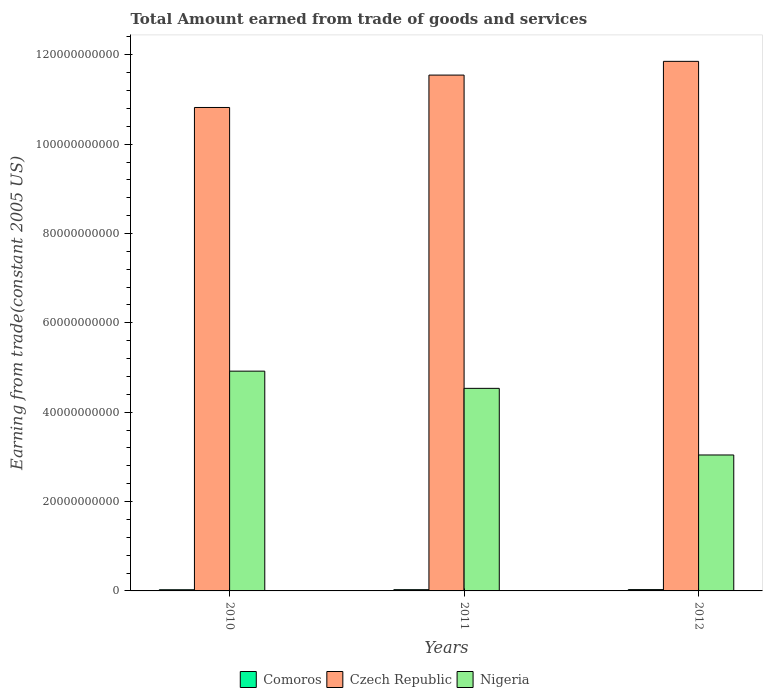How many different coloured bars are there?
Ensure brevity in your answer.  3. Are the number of bars on each tick of the X-axis equal?
Make the answer very short. Yes. How many bars are there on the 2nd tick from the left?
Provide a short and direct response. 3. What is the total amount earned by trading goods and services in Czech Republic in 2011?
Give a very brief answer. 1.15e+11. Across all years, what is the maximum total amount earned by trading goods and services in Nigeria?
Ensure brevity in your answer.  4.92e+1. Across all years, what is the minimum total amount earned by trading goods and services in Comoros?
Your answer should be very brief. 2.64e+08. In which year was the total amount earned by trading goods and services in Czech Republic minimum?
Your answer should be compact. 2010. What is the total total amount earned by trading goods and services in Czech Republic in the graph?
Keep it short and to the point. 3.42e+11. What is the difference between the total amount earned by trading goods and services in Nigeria in 2011 and that in 2012?
Offer a terse response. 1.49e+1. What is the difference between the total amount earned by trading goods and services in Czech Republic in 2010 and the total amount earned by trading goods and services in Nigeria in 2012?
Your answer should be compact. 7.78e+1. What is the average total amount earned by trading goods and services in Nigeria per year?
Ensure brevity in your answer.  4.17e+1. In the year 2011, what is the difference between the total amount earned by trading goods and services in Comoros and total amount earned by trading goods and services in Nigeria?
Give a very brief answer. -4.51e+1. In how many years, is the total amount earned by trading goods and services in Comoros greater than 28000000000 US$?
Offer a terse response. 0. What is the ratio of the total amount earned by trading goods and services in Comoros in 2011 to that in 2012?
Offer a very short reply. 0.94. Is the difference between the total amount earned by trading goods and services in Comoros in 2011 and 2012 greater than the difference between the total amount earned by trading goods and services in Nigeria in 2011 and 2012?
Offer a very short reply. No. What is the difference between the highest and the second highest total amount earned by trading goods and services in Nigeria?
Ensure brevity in your answer.  3.85e+09. What is the difference between the highest and the lowest total amount earned by trading goods and services in Comoros?
Your answer should be compact. 3.07e+07. In how many years, is the total amount earned by trading goods and services in Comoros greater than the average total amount earned by trading goods and services in Comoros taken over all years?
Your answer should be compact. 1. Is the sum of the total amount earned by trading goods and services in Comoros in 2011 and 2012 greater than the maximum total amount earned by trading goods and services in Czech Republic across all years?
Offer a very short reply. No. What does the 3rd bar from the left in 2012 represents?
Your answer should be very brief. Nigeria. What does the 2nd bar from the right in 2012 represents?
Your answer should be very brief. Czech Republic. How many bars are there?
Ensure brevity in your answer.  9. How many years are there in the graph?
Keep it short and to the point. 3. What is the difference between two consecutive major ticks on the Y-axis?
Offer a very short reply. 2.00e+1. Does the graph contain grids?
Provide a short and direct response. No. Where does the legend appear in the graph?
Offer a terse response. Bottom center. How many legend labels are there?
Your answer should be very brief. 3. What is the title of the graph?
Provide a succinct answer. Total Amount earned from trade of goods and services. What is the label or title of the X-axis?
Make the answer very short. Years. What is the label or title of the Y-axis?
Provide a short and direct response. Earning from trade(constant 2005 US). What is the Earning from trade(constant 2005 US) in Comoros in 2010?
Your response must be concise. 2.64e+08. What is the Earning from trade(constant 2005 US) of Czech Republic in 2010?
Your answer should be compact. 1.08e+11. What is the Earning from trade(constant 2005 US) of Nigeria in 2010?
Your answer should be compact. 4.92e+1. What is the Earning from trade(constant 2005 US) of Comoros in 2011?
Make the answer very short. 2.78e+08. What is the Earning from trade(constant 2005 US) of Czech Republic in 2011?
Your answer should be compact. 1.15e+11. What is the Earning from trade(constant 2005 US) in Nigeria in 2011?
Ensure brevity in your answer.  4.53e+1. What is the Earning from trade(constant 2005 US) of Comoros in 2012?
Offer a terse response. 2.95e+08. What is the Earning from trade(constant 2005 US) of Czech Republic in 2012?
Your answer should be compact. 1.19e+11. What is the Earning from trade(constant 2005 US) of Nigeria in 2012?
Your response must be concise. 3.04e+1. Across all years, what is the maximum Earning from trade(constant 2005 US) of Comoros?
Provide a short and direct response. 2.95e+08. Across all years, what is the maximum Earning from trade(constant 2005 US) in Czech Republic?
Offer a terse response. 1.19e+11. Across all years, what is the maximum Earning from trade(constant 2005 US) of Nigeria?
Offer a terse response. 4.92e+1. Across all years, what is the minimum Earning from trade(constant 2005 US) in Comoros?
Your answer should be very brief. 2.64e+08. Across all years, what is the minimum Earning from trade(constant 2005 US) of Czech Republic?
Keep it short and to the point. 1.08e+11. Across all years, what is the minimum Earning from trade(constant 2005 US) of Nigeria?
Give a very brief answer. 3.04e+1. What is the total Earning from trade(constant 2005 US) of Comoros in the graph?
Give a very brief answer. 8.37e+08. What is the total Earning from trade(constant 2005 US) of Czech Republic in the graph?
Provide a short and direct response. 3.42e+11. What is the total Earning from trade(constant 2005 US) in Nigeria in the graph?
Offer a terse response. 1.25e+11. What is the difference between the Earning from trade(constant 2005 US) of Comoros in 2010 and that in 2011?
Provide a short and direct response. -1.44e+07. What is the difference between the Earning from trade(constant 2005 US) of Czech Republic in 2010 and that in 2011?
Keep it short and to the point. -7.25e+09. What is the difference between the Earning from trade(constant 2005 US) of Nigeria in 2010 and that in 2011?
Ensure brevity in your answer.  3.85e+09. What is the difference between the Earning from trade(constant 2005 US) of Comoros in 2010 and that in 2012?
Give a very brief answer. -3.07e+07. What is the difference between the Earning from trade(constant 2005 US) of Czech Republic in 2010 and that in 2012?
Keep it short and to the point. -1.03e+1. What is the difference between the Earning from trade(constant 2005 US) in Nigeria in 2010 and that in 2012?
Ensure brevity in your answer.  1.88e+1. What is the difference between the Earning from trade(constant 2005 US) in Comoros in 2011 and that in 2012?
Your answer should be very brief. -1.63e+07. What is the difference between the Earning from trade(constant 2005 US) of Czech Republic in 2011 and that in 2012?
Offer a terse response. -3.07e+09. What is the difference between the Earning from trade(constant 2005 US) in Nigeria in 2011 and that in 2012?
Provide a short and direct response. 1.49e+1. What is the difference between the Earning from trade(constant 2005 US) in Comoros in 2010 and the Earning from trade(constant 2005 US) in Czech Republic in 2011?
Your answer should be compact. -1.15e+11. What is the difference between the Earning from trade(constant 2005 US) in Comoros in 2010 and the Earning from trade(constant 2005 US) in Nigeria in 2011?
Provide a succinct answer. -4.51e+1. What is the difference between the Earning from trade(constant 2005 US) in Czech Republic in 2010 and the Earning from trade(constant 2005 US) in Nigeria in 2011?
Keep it short and to the point. 6.29e+1. What is the difference between the Earning from trade(constant 2005 US) in Comoros in 2010 and the Earning from trade(constant 2005 US) in Czech Republic in 2012?
Provide a succinct answer. -1.18e+11. What is the difference between the Earning from trade(constant 2005 US) in Comoros in 2010 and the Earning from trade(constant 2005 US) in Nigeria in 2012?
Give a very brief answer. -3.02e+1. What is the difference between the Earning from trade(constant 2005 US) of Czech Republic in 2010 and the Earning from trade(constant 2005 US) of Nigeria in 2012?
Make the answer very short. 7.78e+1. What is the difference between the Earning from trade(constant 2005 US) in Comoros in 2011 and the Earning from trade(constant 2005 US) in Czech Republic in 2012?
Offer a terse response. -1.18e+11. What is the difference between the Earning from trade(constant 2005 US) in Comoros in 2011 and the Earning from trade(constant 2005 US) in Nigeria in 2012?
Offer a terse response. -3.01e+1. What is the difference between the Earning from trade(constant 2005 US) of Czech Republic in 2011 and the Earning from trade(constant 2005 US) of Nigeria in 2012?
Make the answer very short. 8.50e+1. What is the average Earning from trade(constant 2005 US) of Comoros per year?
Your answer should be compact. 2.79e+08. What is the average Earning from trade(constant 2005 US) in Czech Republic per year?
Provide a succinct answer. 1.14e+11. What is the average Earning from trade(constant 2005 US) of Nigeria per year?
Offer a terse response. 4.17e+1. In the year 2010, what is the difference between the Earning from trade(constant 2005 US) of Comoros and Earning from trade(constant 2005 US) of Czech Republic?
Give a very brief answer. -1.08e+11. In the year 2010, what is the difference between the Earning from trade(constant 2005 US) in Comoros and Earning from trade(constant 2005 US) in Nigeria?
Your response must be concise. -4.89e+1. In the year 2010, what is the difference between the Earning from trade(constant 2005 US) in Czech Republic and Earning from trade(constant 2005 US) in Nigeria?
Make the answer very short. 5.90e+1. In the year 2011, what is the difference between the Earning from trade(constant 2005 US) of Comoros and Earning from trade(constant 2005 US) of Czech Republic?
Provide a succinct answer. -1.15e+11. In the year 2011, what is the difference between the Earning from trade(constant 2005 US) of Comoros and Earning from trade(constant 2005 US) of Nigeria?
Your answer should be very brief. -4.51e+1. In the year 2011, what is the difference between the Earning from trade(constant 2005 US) in Czech Republic and Earning from trade(constant 2005 US) in Nigeria?
Your answer should be compact. 7.01e+1. In the year 2012, what is the difference between the Earning from trade(constant 2005 US) of Comoros and Earning from trade(constant 2005 US) of Czech Republic?
Keep it short and to the point. -1.18e+11. In the year 2012, what is the difference between the Earning from trade(constant 2005 US) in Comoros and Earning from trade(constant 2005 US) in Nigeria?
Provide a succinct answer. -3.01e+1. In the year 2012, what is the difference between the Earning from trade(constant 2005 US) of Czech Republic and Earning from trade(constant 2005 US) of Nigeria?
Give a very brief answer. 8.81e+1. What is the ratio of the Earning from trade(constant 2005 US) of Comoros in 2010 to that in 2011?
Your response must be concise. 0.95. What is the ratio of the Earning from trade(constant 2005 US) in Czech Republic in 2010 to that in 2011?
Make the answer very short. 0.94. What is the ratio of the Earning from trade(constant 2005 US) of Nigeria in 2010 to that in 2011?
Your response must be concise. 1.08. What is the ratio of the Earning from trade(constant 2005 US) of Comoros in 2010 to that in 2012?
Keep it short and to the point. 0.9. What is the ratio of the Earning from trade(constant 2005 US) in Czech Republic in 2010 to that in 2012?
Provide a short and direct response. 0.91. What is the ratio of the Earning from trade(constant 2005 US) of Nigeria in 2010 to that in 2012?
Ensure brevity in your answer.  1.62. What is the ratio of the Earning from trade(constant 2005 US) of Comoros in 2011 to that in 2012?
Your response must be concise. 0.94. What is the ratio of the Earning from trade(constant 2005 US) in Czech Republic in 2011 to that in 2012?
Your response must be concise. 0.97. What is the ratio of the Earning from trade(constant 2005 US) in Nigeria in 2011 to that in 2012?
Provide a succinct answer. 1.49. What is the difference between the highest and the second highest Earning from trade(constant 2005 US) of Comoros?
Your answer should be compact. 1.63e+07. What is the difference between the highest and the second highest Earning from trade(constant 2005 US) in Czech Republic?
Make the answer very short. 3.07e+09. What is the difference between the highest and the second highest Earning from trade(constant 2005 US) in Nigeria?
Provide a succinct answer. 3.85e+09. What is the difference between the highest and the lowest Earning from trade(constant 2005 US) of Comoros?
Provide a short and direct response. 3.07e+07. What is the difference between the highest and the lowest Earning from trade(constant 2005 US) in Czech Republic?
Offer a terse response. 1.03e+1. What is the difference between the highest and the lowest Earning from trade(constant 2005 US) in Nigeria?
Provide a succinct answer. 1.88e+1. 